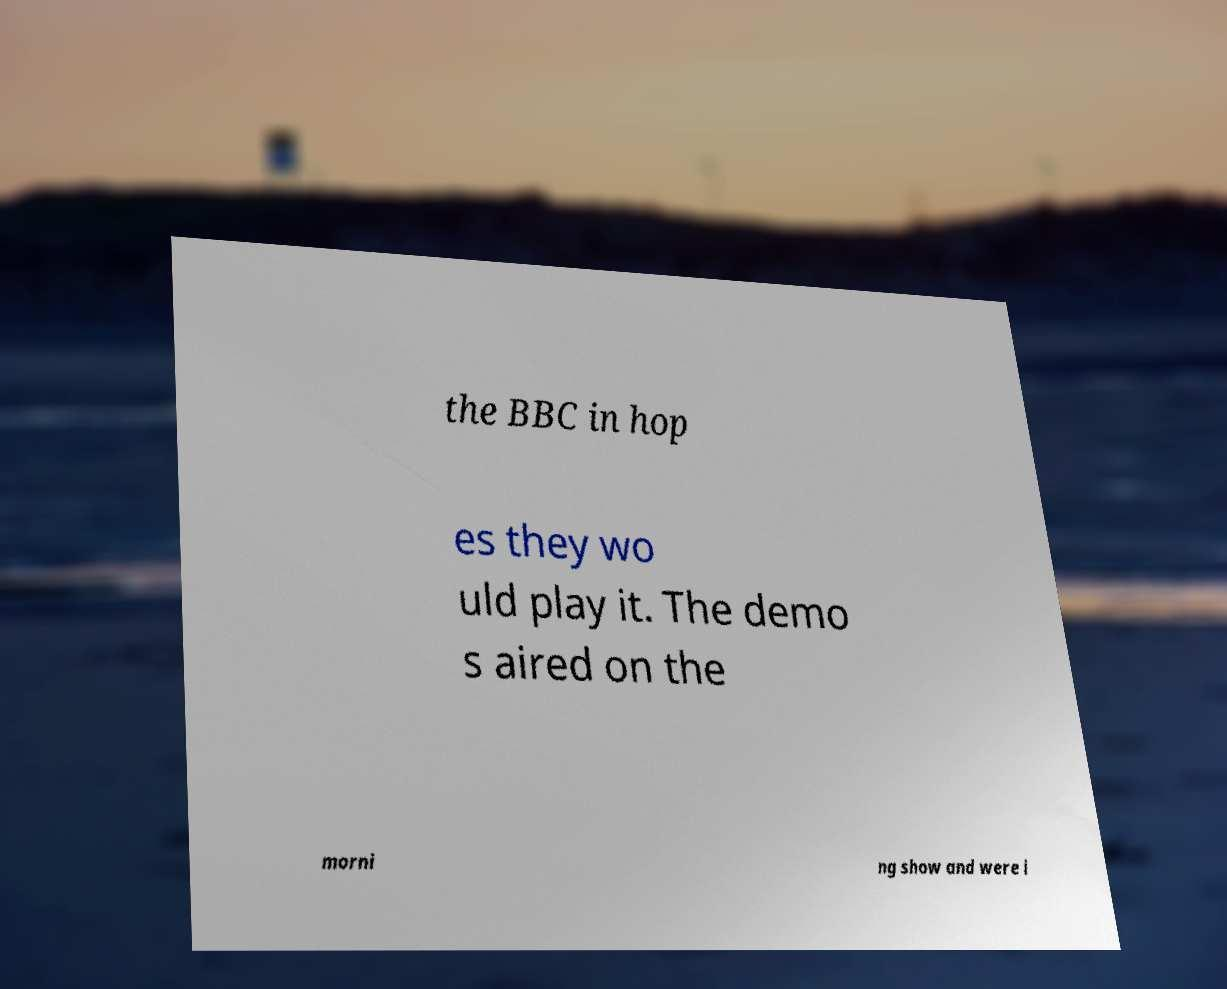Can you read and provide the text displayed in the image?This photo seems to have some interesting text. Can you extract and type it out for me? the BBC in hop es they wo uld play it. The demo s aired on the morni ng show and were i 